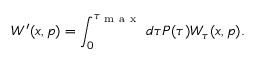<formula> <loc_0><loc_0><loc_500><loc_500>W ^ { \prime } ( x , p ) = \int _ { 0 } ^ { \tau _ { m a x } } d \tau P ( \tau ) W _ { \tau } ( x , p ) .</formula> 